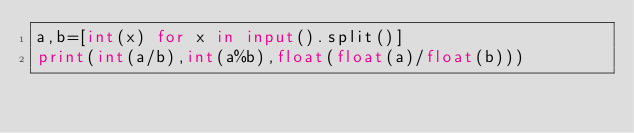Convert code to text. <code><loc_0><loc_0><loc_500><loc_500><_Python_>a,b=[int(x) for x in input().split()]
print(int(a/b),int(a%b),float(float(a)/float(b)))
</code> 